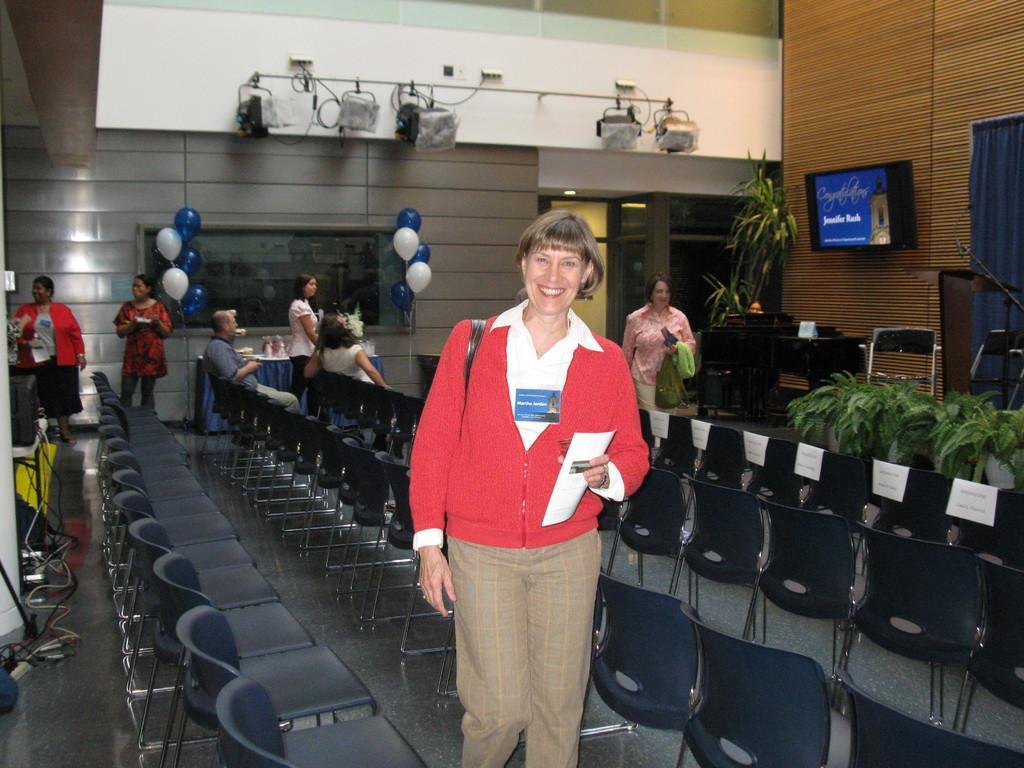Describe this image in one or two sentences. In this image we can see a woman is standing. She is holding an object in her hand and carrying bag. In the background, we can see so many chairs, plants, people and balloons. At the top of the image, we can see the lights and the wall. On the right side of the image, we can see a podium, mic, curtain and monitor. We can see some wires and objects on the left side of the image. 